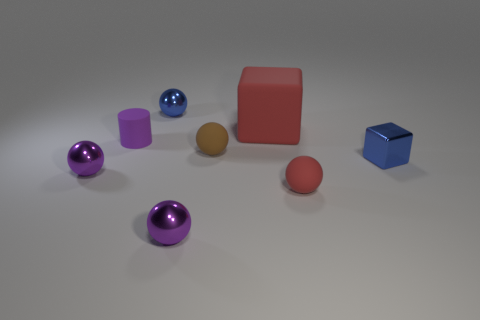Subtract all blue balls. How many balls are left? 4 Subtract all blue metal balls. How many balls are left? 4 Add 1 brown objects. How many objects exist? 9 Subtract all purple spheres. Subtract all red blocks. How many spheres are left? 3 Subtract all blocks. How many objects are left? 6 Add 6 tiny shiny cubes. How many tiny shiny cubes exist? 7 Subtract 0 cyan blocks. How many objects are left? 8 Subtract all tiny green shiny objects. Subtract all purple cylinders. How many objects are left? 7 Add 1 blue spheres. How many blue spheres are left? 2 